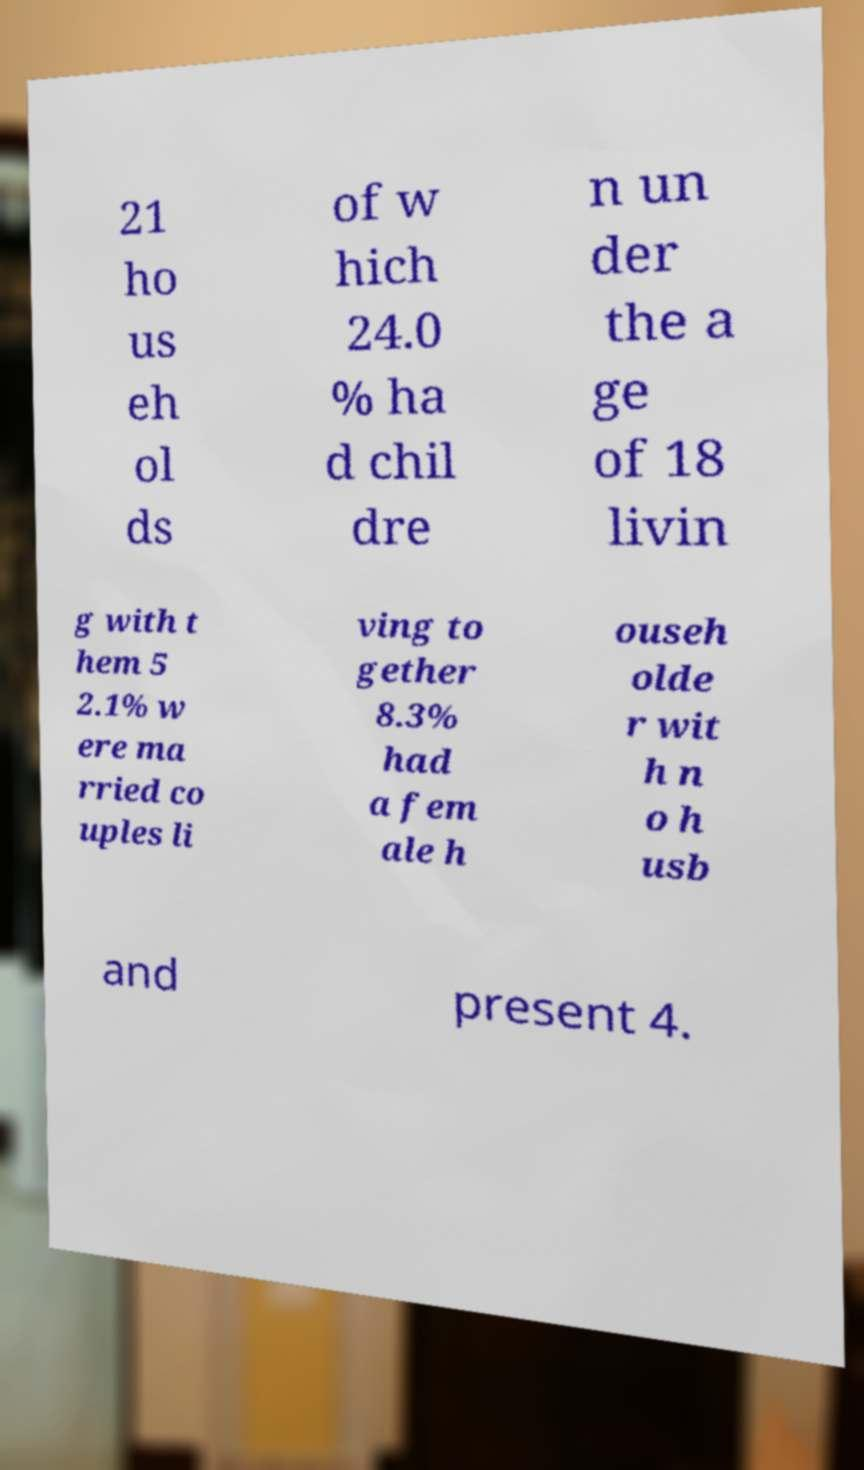Can you accurately transcribe the text from the provided image for me? 21 ho us eh ol ds of w hich 24.0 % ha d chil dre n un der the a ge of 18 livin g with t hem 5 2.1% w ere ma rried co uples li ving to gether 8.3% had a fem ale h ouseh olde r wit h n o h usb and present 4. 